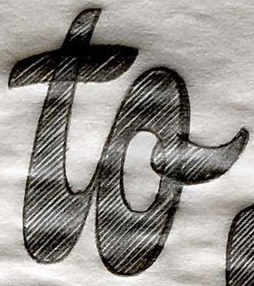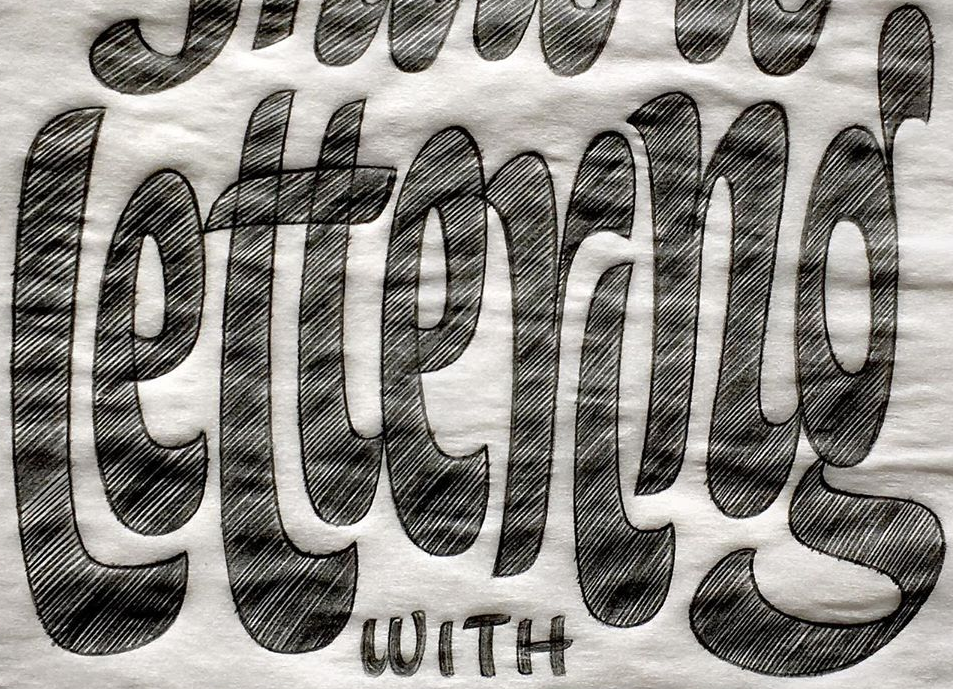Identify the words shown in these images in order, separated by a semicolon. to; lettering 